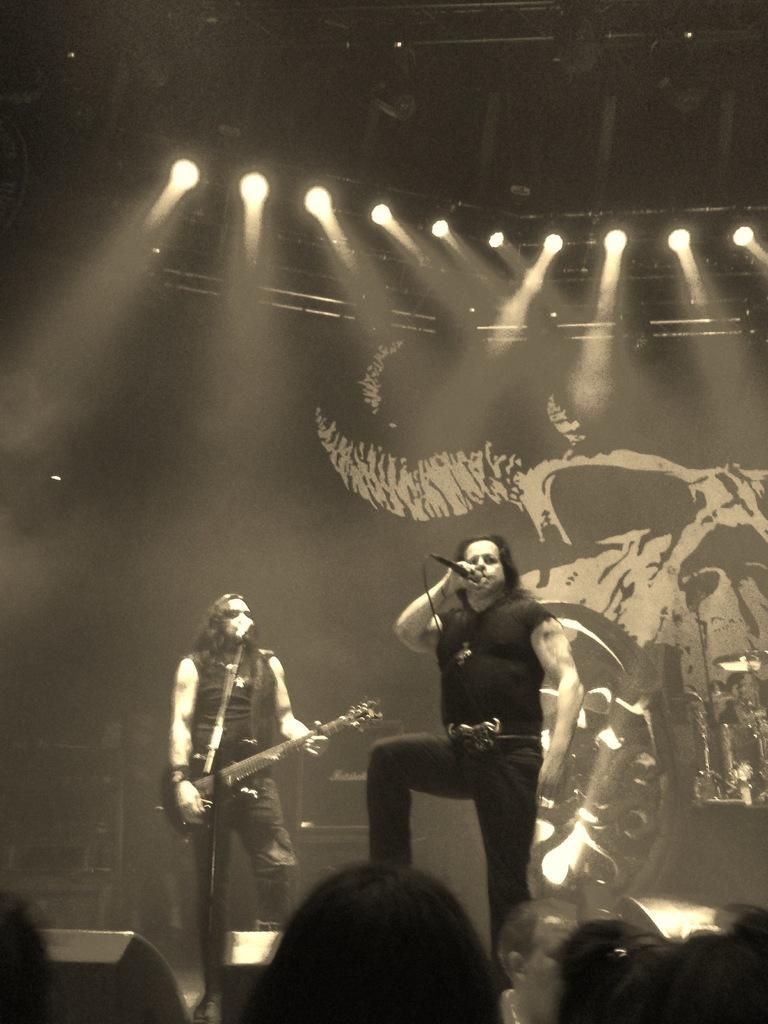How many people are in the image? There are two persons in the image. What are the two persons doing in the image? The two persons are playing a musical instrument. What color is the bone that the person is holding in the image? There is no bone present in the image; the two persons are playing a musical instrument. 